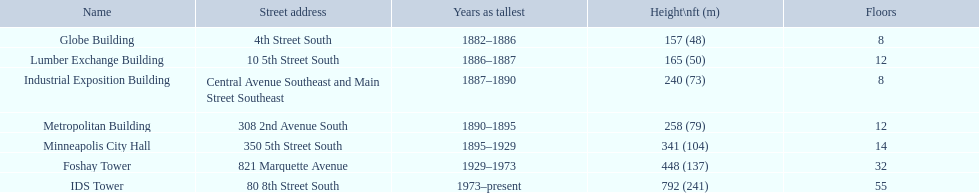During what years was 240 feet regarded as tall? 1887–1890. What building had this achievement? Industrial Exposition Building. 